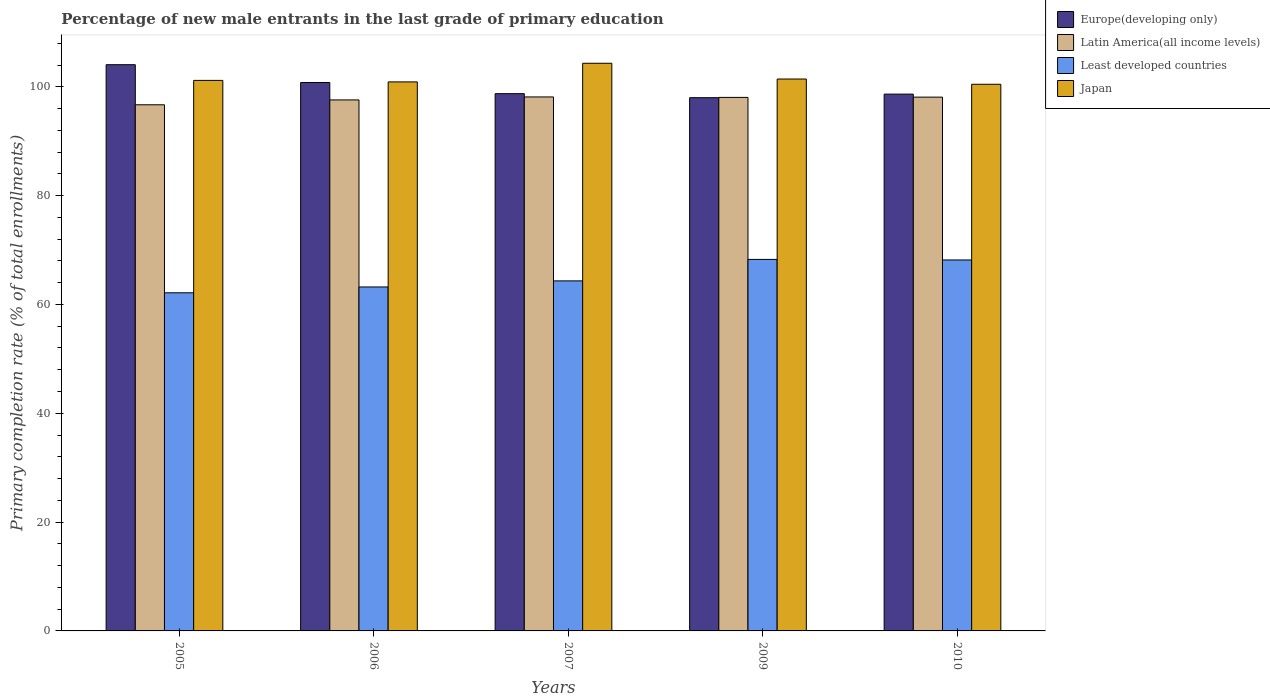How many groups of bars are there?
Provide a short and direct response. 5. Are the number of bars per tick equal to the number of legend labels?
Your response must be concise. Yes. What is the label of the 1st group of bars from the left?
Provide a short and direct response. 2005. In how many cases, is the number of bars for a given year not equal to the number of legend labels?
Give a very brief answer. 0. What is the percentage of new male entrants in Least developed countries in 2005?
Provide a succinct answer. 62.14. Across all years, what is the maximum percentage of new male entrants in Europe(developing only)?
Your answer should be compact. 104.07. Across all years, what is the minimum percentage of new male entrants in Europe(developing only)?
Your answer should be compact. 98. In which year was the percentage of new male entrants in Europe(developing only) maximum?
Your answer should be compact. 2005. What is the total percentage of new male entrants in Least developed countries in the graph?
Provide a short and direct response. 326.15. What is the difference between the percentage of new male entrants in Latin America(all income levels) in 2006 and that in 2009?
Keep it short and to the point. -0.46. What is the difference between the percentage of new male entrants in Japan in 2007 and the percentage of new male entrants in Least developed countries in 2010?
Give a very brief answer. 36.15. What is the average percentage of new male entrants in Least developed countries per year?
Your answer should be compact. 65.23. In the year 2007, what is the difference between the percentage of new male entrants in Least developed countries and percentage of new male entrants in Latin America(all income levels)?
Your response must be concise. -33.81. In how many years, is the percentage of new male entrants in Europe(developing only) greater than 100 %?
Give a very brief answer. 2. What is the ratio of the percentage of new male entrants in Latin America(all income levels) in 2006 to that in 2010?
Your answer should be compact. 0.99. Is the percentage of new male entrants in Latin America(all income levels) in 2005 less than that in 2007?
Keep it short and to the point. Yes. Is the difference between the percentage of new male entrants in Least developed countries in 2006 and 2007 greater than the difference between the percentage of new male entrants in Latin America(all income levels) in 2006 and 2007?
Offer a terse response. No. What is the difference between the highest and the second highest percentage of new male entrants in Japan?
Keep it short and to the point. 2.9. What is the difference between the highest and the lowest percentage of new male entrants in Europe(developing only)?
Ensure brevity in your answer.  6.06. Is the sum of the percentage of new male entrants in Latin America(all income levels) in 2005 and 2010 greater than the maximum percentage of new male entrants in Least developed countries across all years?
Offer a very short reply. Yes. Is it the case that in every year, the sum of the percentage of new male entrants in Latin America(all income levels) and percentage of new male entrants in Europe(developing only) is greater than the sum of percentage of new male entrants in Japan and percentage of new male entrants in Least developed countries?
Make the answer very short. Yes. How many bars are there?
Provide a succinct answer. 20. Are all the bars in the graph horizontal?
Your answer should be very brief. No. How many years are there in the graph?
Provide a succinct answer. 5. Does the graph contain any zero values?
Your answer should be very brief. No. Does the graph contain grids?
Offer a terse response. No. How many legend labels are there?
Provide a short and direct response. 4. What is the title of the graph?
Make the answer very short. Percentage of new male entrants in the last grade of primary education. Does "Venezuela" appear as one of the legend labels in the graph?
Give a very brief answer. No. What is the label or title of the X-axis?
Provide a succinct answer. Years. What is the label or title of the Y-axis?
Your answer should be very brief. Primary completion rate (% of total enrollments). What is the Primary completion rate (% of total enrollments) of Europe(developing only) in 2005?
Make the answer very short. 104.07. What is the Primary completion rate (% of total enrollments) of Latin America(all income levels) in 2005?
Ensure brevity in your answer.  96.7. What is the Primary completion rate (% of total enrollments) of Least developed countries in 2005?
Make the answer very short. 62.14. What is the Primary completion rate (% of total enrollments) in Japan in 2005?
Offer a very short reply. 101.18. What is the Primary completion rate (% of total enrollments) in Europe(developing only) in 2006?
Keep it short and to the point. 100.79. What is the Primary completion rate (% of total enrollments) in Latin America(all income levels) in 2006?
Provide a succinct answer. 97.59. What is the Primary completion rate (% of total enrollments) in Least developed countries in 2006?
Provide a succinct answer. 63.22. What is the Primary completion rate (% of total enrollments) of Japan in 2006?
Make the answer very short. 100.9. What is the Primary completion rate (% of total enrollments) of Europe(developing only) in 2007?
Your response must be concise. 98.74. What is the Primary completion rate (% of total enrollments) in Latin America(all income levels) in 2007?
Keep it short and to the point. 98.14. What is the Primary completion rate (% of total enrollments) of Least developed countries in 2007?
Provide a short and direct response. 64.33. What is the Primary completion rate (% of total enrollments) in Japan in 2007?
Keep it short and to the point. 104.33. What is the Primary completion rate (% of total enrollments) in Europe(developing only) in 2009?
Keep it short and to the point. 98. What is the Primary completion rate (% of total enrollments) in Latin America(all income levels) in 2009?
Ensure brevity in your answer.  98.06. What is the Primary completion rate (% of total enrollments) in Least developed countries in 2009?
Give a very brief answer. 68.28. What is the Primary completion rate (% of total enrollments) in Japan in 2009?
Ensure brevity in your answer.  101.43. What is the Primary completion rate (% of total enrollments) of Europe(developing only) in 2010?
Your answer should be compact. 98.66. What is the Primary completion rate (% of total enrollments) of Latin America(all income levels) in 2010?
Provide a succinct answer. 98.1. What is the Primary completion rate (% of total enrollments) of Least developed countries in 2010?
Offer a terse response. 68.18. What is the Primary completion rate (% of total enrollments) in Japan in 2010?
Provide a succinct answer. 100.47. Across all years, what is the maximum Primary completion rate (% of total enrollments) in Europe(developing only)?
Give a very brief answer. 104.07. Across all years, what is the maximum Primary completion rate (% of total enrollments) in Latin America(all income levels)?
Provide a succinct answer. 98.14. Across all years, what is the maximum Primary completion rate (% of total enrollments) of Least developed countries?
Your answer should be very brief. 68.28. Across all years, what is the maximum Primary completion rate (% of total enrollments) in Japan?
Your response must be concise. 104.33. Across all years, what is the minimum Primary completion rate (% of total enrollments) in Europe(developing only)?
Your answer should be compact. 98. Across all years, what is the minimum Primary completion rate (% of total enrollments) of Latin America(all income levels)?
Your answer should be compact. 96.7. Across all years, what is the minimum Primary completion rate (% of total enrollments) of Least developed countries?
Your answer should be very brief. 62.14. Across all years, what is the minimum Primary completion rate (% of total enrollments) in Japan?
Ensure brevity in your answer.  100.47. What is the total Primary completion rate (% of total enrollments) of Europe(developing only) in the graph?
Offer a very short reply. 500.26. What is the total Primary completion rate (% of total enrollments) of Latin America(all income levels) in the graph?
Your answer should be compact. 488.59. What is the total Primary completion rate (% of total enrollments) of Least developed countries in the graph?
Keep it short and to the point. 326.15. What is the total Primary completion rate (% of total enrollments) in Japan in the graph?
Make the answer very short. 508.31. What is the difference between the Primary completion rate (% of total enrollments) of Europe(developing only) in 2005 and that in 2006?
Your answer should be very brief. 3.28. What is the difference between the Primary completion rate (% of total enrollments) of Latin America(all income levels) in 2005 and that in 2006?
Make the answer very short. -0.9. What is the difference between the Primary completion rate (% of total enrollments) in Least developed countries in 2005 and that in 2006?
Your answer should be very brief. -1.07. What is the difference between the Primary completion rate (% of total enrollments) in Japan in 2005 and that in 2006?
Your answer should be very brief. 0.28. What is the difference between the Primary completion rate (% of total enrollments) in Europe(developing only) in 2005 and that in 2007?
Provide a succinct answer. 5.32. What is the difference between the Primary completion rate (% of total enrollments) in Latin America(all income levels) in 2005 and that in 2007?
Provide a succinct answer. -1.44. What is the difference between the Primary completion rate (% of total enrollments) of Least developed countries in 2005 and that in 2007?
Make the answer very short. -2.19. What is the difference between the Primary completion rate (% of total enrollments) of Japan in 2005 and that in 2007?
Keep it short and to the point. -3.15. What is the difference between the Primary completion rate (% of total enrollments) in Europe(developing only) in 2005 and that in 2009?
Provide a succinct answer. 6.06. What is the difference between the Primary completion rate (% of total enrollments) in Latin America(all income levels) in 2005 and that in 2009?
Your answer should be very brief. -1.36. What is the difference between the Primary completion rate (% of total enrollments) in Least developed countries in 2005 and that in 2009?
Provide a short and direct response. -6.14. What is the difference between the Primary completion rate (% of total enrollments) of Japan in 2005 and that in 2009?
Your answer should be compact. -0.25. What is the difference between the Primary completion rate (% of total enrollments) in Europe(developing only) in 2005 and that in 2010?
Give a very brief answer. 5.41. What is the difference between the Primary completion rate (% of total enrollments) of Latin America(all income levels) in 2005 and that in 2010?
Offer a terse response. -1.41. What is the difference between the Primary completion rate (% of total enrollments) of Least developed countries in 2005 and that in 2010?
Offer a very short reply. -6.04. What is the difference between the Primary completion rate (% of total enrollments) in Japan in 2005 and that in 2010?
Offer a terse response. 0.71. What is the difference between the Primary completion rate (% of total enrollments) of Europe(developing only) in 2006 and that in 2007?
Keep it short and to the point. 2.05. What is the difference between the Primary completion rate (% of total enrollments) in Latin America(all income levels) in 2006 and that in 2007?
Your response must be concise. -0.54. What is the difference between the Primary completion rate (% of total enrollments) in Least developed countries in 2006 and that in 2007?
Give a very brief answer. -1.12. What is the difference between the Primary completion rate (% of total enrollments) of Japan in 2006 and that in 2007?
Provide a succinct answer. -3.43. What is the difference between the Primary completion rate (% of total enrollments) of Europe(developing only) in 2006 and that in 2009?
Your response must be concise. 2.79. What is the difference between the Primary completion rate (% of total enrollments) in Latin America(all income levels) in 2006 and that in 2009?
Ensure brevity in your answer.  -0.46. What is the difference between the Primary completion rate (% of total enrollments) of Least developed countries in 2006 and that in 2009?
Your answer should be very brief. -5.06. What is the difference between the Primary completion rate (% of total enrollments) in Japan in 2006 and that in 2009?
Your answer should be compact. -0.53. What is the difference between the Primary completion rate (% of total enrollments) in Europe(developing only) in 2006 and that in 2010?
Your response must be concise. 2.13. What is the difference between the Primary completion rate (% of total enrollments) of Latin America(all income levels) in 2006 and that in 2010?
Provide a succinct answer. -0.51. What is the difference between the Primary completion rate (% of total enrollments) in Least developed countries in 2006 and that in 2010?
Offer a very short reply. -4.96. What is the difference between the Primary completion rate (% of total enrollments) of Japan in 2006 and that in 2010?
Your answer should be very brief. 0.44. What is the difference between the Primary completion rate (% of total enrollments) of Europe(developing only) in 2007 and that in 2009?
Make the answer very short. 0.74. What is the difference between the Primary completion rate (% of total enrollments) in Latin America(all income levels) in 2007 and that in 2009?
Offer a very short reply. 0.08. What is the difference between the Primary completion rate (% of total enrollments) of Least developed countries in 2007 and that in 2009?
Your answer should be very brief. -3.95. What is the difference between the Primary completion rate (% of total enrollments) in Japan in 2007 and that in 2009?
Your answer should be very brief. 2.9. What is the difference between the Primary completion rate (% of total enrollments) of Europe(developing only) in 2007 and that in 2010?
Your response must be concise. 0.08. What is the difference between the Primary completion rate (% of total enrollments) of Latin America(all income levels) in 2007 and that in 2010?
Ensure brevity in your answer.  0.03. What is the difference between the Primary completion rate (% of total enrollments) of Least developed countries in 2007 and that in 2010?
Your answer should be very brief. -3.85. What is the difference between the Primary completion rate (% of total enrollments) of Japan in 2007 and that in 2010?
Provide a succinct answer. 3.86. What is the difference between the Primary completion rate (% of total enrollments) of Europe(developing only) in 2009 and that in 2010?
Offer a very short reply. -0.65. What is the difference between the Primary completion rate (% of total enrollments) of Latin America(all income levels) in 2009 and that in 2010?
Give a very brief answer. -0.05. What is the difference between the Primary completion rate (% of total enrollments) in Least developed countries in 2009 and that in 2010?
Ensure brevity in your answer.  0.1. What is the difference between the Primary completion rate (% of total enrollments) in Japan in 2009 and that in 2010?
Your answer should be very brief. 0.97. What is the difference between the Primary completion rate (% of total enrollments) in Europe(developing only) in 2005 and the Primary completion rate (% of total enrollments) in Latin America(all income levels) in 2006?
Give a very brief answer. 6.47. What is the difference between the Primary completion rate (% of total enrollments) in Europe(developing only) in 2005 and the Primary completion rate (% of total enrollments) in Least developed countries in 2006?
Keep it short and to the point. 40.85. What is the difference between the Primary completion rate (% of total enrollments) in Europe(developing only) in 2005 and the Primary completion rate (% of total enrollments) in Japan in 2006?
Provide a succinct answer. 3.16. What is the difference between the Primary completion rate (% of total enrollments) of Latin America(all income levels) in 2005 and the Primary completion rate (% of total enrollments) of Least developed countries in 2006?
Your response must be concise. 33.48. What is the difference between the Primary completion rate (% of total enrollments) in Latin America(all income levels) in 2005 and the Primary completion rate (% of total enrollments) in Japan in 2006?
Provide a succinct answer. -4.21. What is the difference between the Primary completion rate (% of total enrollments) of Least developed countries in 2005 and the Primary completion rate (% of total enrollments) of Japan in 2006?
Offer a terse response. -38.76. What is the difference between the Primary completion rate (% of total enrollments) of Europe(developing only) in 2005 and the Primary completion rate (% of total enrollments) of Latin America(all income levels) in 2007?
Your answer should be compact. 5.93. What is the difference between the Primary completion rate (% of total enrollments) in Europe(developing only) in 2005 and the Primary completion rate (% of total enrollments) in Least developed countries in 2007?
Provide a succinct answer. 39.73. What is the difference between the Primary completion rate (% of total enrollments) of Europe(developing only) in 2005 and the Primary completion rate (% of total enrollments) of Japan in 2007?
Give a very brief answer. -0.26. What is the difference between the Primary completion rate (% of total enrollments) in Latin America(all income levels) in 2005 and the Primary completion rate (% of total enrollments) in Least developed countries in 2007?
Keep it short and to the point. 32.36. What is the difference between the Primary completion rate (% of total enrollments) in Latin America(all income levels) in 2005 and the Primary completion rate (% of total enrollments) in Japan in 2007?
Your answer should be compact. -7.63. What is the difference between the Primary completion rate (% of total enrollments) of Least developed countries in 2005 and the Primary completion rate (% of total enrollments) of Japan in 2007?
Your answer should be very brief. -42.19. What is the difference between the Primary completion rate (% of total enrollments) of Europe(developing only) in 2005 and the Primary completion rate (% of total enrollments) of Latin America(all income levels) in 2009?
Your answer should be very brief. 6.01. What is the difference between the Primary completion rate (% of total enrollments) in Europe(developing only) in 2005 and the Primary completion rate (% of total enrollments) in Least developed countries in 2009?
Offer a very short reply. 35.79. What is the difference between the Primary completion rate (% of total enrollments) in Europe(developing only) in 2005 and the Primary completion rate (% of total enrollments) in Japan in 2009?
Provide a short and direct response. 2.63. What is the difference between the Primary completion rate (% of total enrollments) of Latin America(all income levels) in 2005 and the Primary completion rate (% of total enrollments) of Least developed countries in 2009?
Offer a terse response. 28.42. What is the difference between the Primary completion rate (% of total enrollments) in Latin America(all income levels) in 2005 and the Primary completion rate (% of total enrollments) in Japan in 2009?
Your answer should be compact. -4.73. What is the difference between the Primary completion rate (% of total enrollments) of Least developed countries in 2005 and the Primary completion rate (% of total enrollments) of Japan in 2009?
Offer a terse response. -39.29. What is the difference between the Primary completion rate (% of total enrollments) in Europe(developing only) in 2005 and the Primary completion rate (% of total enrollments) in Latin America(all income levels) in 2010?
Your answer should be compact. 5.96. What is the difference between the Primary completion rate (% of total enrollments) in Europe(developing only) in 2005 and the Primary completion rate (% of total enrollments) in Least developed countries in 2010?
Keep it short and to the point. 35.89. What is the difference between the Primary completion rate (% of total enrollments) of Europe(developing only) in 2005 and the Primary completion rate (% of total enrollments) of Japan in 2010?
Your answer should be very brief. 3.6. What is the difference between the Primary completion rate (% of total enrollments) in Latin America(all income levels) in 2005 and the Primary completion rate (% of total enrollments) in Least developed countries in 2010?
Make the answer very short. 28.52. What is the difference between the Primary completion rate (% of total enrollments) of Latin America(all income levels) in 2005 and the Primary completion rate (% of total enrollments) of Japan in 2010?
Offer a terse response. -3.77. What is the difference between the Primary completion rate (% of total enrollments) of Least developed countries in 2005 and the Primary completion rate (% of total enrollments) of Japan in 2010?
Your answer should be compact. -38.32. What is the difference between the Primary completion rate (% of total enrollments) in Europe(developing only) in 2006 and the Primary completion rate (% of total enrollments) in Latin America(all income levels) in 2007?
Keep it short and to the point. 2.65. What is the difference between the Primary completion rate (% of total enrollments) of Europe(developing only) in 2006 and the Primary completion rate (% of total enrollments) of Least developed countries in 2007?
Offer a terse response. 36.46. What is the difference between the Primary completion rate (% of total enrollments) in Europe(developing only) in 2006 and the Primary completion rate (% of total enrollments) in Japan in 2007?
Keep it short and to the point. -3.54. What is the difference between the Primary completion rate (% of total enrollments) in Latin America(all income levels) in 2006 and the Primary completion rate (% of total enrollments) in Least developed countries in 2007?
Give a very brief answer. 33.26. What is the difference between the Primary completion rate (% of total enrollments) in Latin America(all income levels) in 2006 and the Primary completion rate (% of total enrollments) in Japan in 2007?
Your response must be concise. -6.74. What is the difference between the Primary completion rate (% of total enrollments) of Least developed countries in 2006 and the Primary completion rate (% of total enrollments) of Japan in 2007?
Make the answer very short. -41.11. What is the difference between the Primary completion rate (% of total enrollments) of Europe(developing only) in 2006 and the Primary completion rate (% of total enrollments) of Latin America(all income levels) in 2009?
Offer a very short reply. 2.74. What is the difference between the Primary completion rate (% of total enrollments) of Europe(developing only) in 2006 and the Primary completion rate (% of total enrollments) of Least developed countries in 2009?
Offer a very short reply. 32.51. What is the difference between the Primary completion rate (% of total enrollments) in Europe(developing only) in 2006 and the Primary completion rate (% of total enrollments) in Japan in 2009?
Your answer should be compact. -0.64. What is the difference between the Primary completion rate (% of total enrollments) of Latin America(all income levels) in 2006 and the Primary completion rate (% of total enrollments) of Least developed countries in 2009?
Offer a terse response. 29.31. What is the difference between the Primary completion rate (% of total enrollments) in Latin America(all income levels) in 2006 and the Primary completion rate (% of total enrollments) in Japan in 2009?
Make the answer very short. -3.84. What is the difference between the Primary completion rate (% of total enrollments) in Least developed countries in 2006 and the Primary completion rate (% of total enrollments) in Japan in 2009?
Make the answer very short. -38.22. What is the difference between the Primary completion rate (% of total enrollments) in Europe(developing only) in 2006 and the Primary completion rate (% of total enrollments) in Latin America(all income levels) in 2010?
Provide a succinct answer. 2.69. What is the difference between the Primary completion rate (% of total enrollments) of Europe(developing only) in 2006 and the Primary completion rate (% of total enrollments) of Least developed countries in 2010?
Offer a terse response. 32.61. What is the difference between the Primary completion rate (% of total enrollments) of Europe(developing only) in 2006 and the Primary completion rate (% of total enrollments) of Japan in 2010?
Offer a very short reply. 0.32. What is the difference between the Primary completion rate (% of total enrollments) in Latin America(all income levels) in 2006 and the Primary completion rate (% of total enrollments) in Least developed countries in 2010?
Provide a succinct answer. 29.41. What is the difference between the Primary completion rate (% of total enrollments) in Latin America(all income levels) in 2006 and the Primary completion rate (% of total enrollments) in Japan in 2010?
Give a very brief answer. -2.87. What is the difference between the Primary completion rate (% of total enrollments) of Least developed countries in 2006 and the Primary completion rate (% of total enrollments) of Japan in 2010?
Give a very brief answer. -37.25. What is the difference between the Primary completion rate (% of total enrollments) in Europe(developing only) in 2007 and the Primary completion rate (% of total enrollments) in Latin America(all income levels) in 2009?
Provide a succinct answer. 0.69. What is the difference between the Primary completion rate (% of total enrollments) in Europe(developing only) in 2007 and the Primary completion rate (% of total enrollments) in Least developed countries in 2009?
Your response must be concise. 30.46. What is the difference between the Primary completion rate (% of total enrollments) in Europe(developing only) in 2007 and the Primary completion rate (% of total enrollments) in Japan in 2009?
Your answer should be compact. -2.69. What is the difference between the Primary completion rate (% of total enrollments) of Latin America(all income levels) in 2007 and the Primary completion rate (% of total enrollments) of Least developed countries in 2009?
Keep it short and to the point. 29.86. What is the difference between the Primary completion rate (% of total enrollments) in Latin America(all income levels) in 2007 and the Primary completion rate (% of total enrollments) in Japan in 2009?
Offer a very short reply. -3.29. What is the difference between the Primary completion rate (% of total enrollments) of Least developed countries in 2007 and the Primary completion rate (% of total enrollments) of Japan in 2009?
Offer a very short reply. -37.1. What is the difference between the Primary completion rate (% of total enrollments) in Europe(developing only) in 2007 and the Primary completion rate (% of total enrollments) in Latin America(all income levels) in 2010?
Your answer should be compact. 0.64. What is the difference between the Primary completion rate (% of total enrollments) in Europe(developing only) in 2007 and the Primary completion rate (% of total enrollments) in Least developed countries in 2010?
Give a very brief answer. 30.56. What is the difference between the Primary completion rate (% of total enrollments) of Europe(developing only) in 2007 and the Primary completion rate (% of total enrollments) of Japan in 2010?
Offer a terse response. -1.73. What is the difference between the Primary completion rate (% of total enrollments) in Latin America(all income levels) in 2007 and the Primary completion rate (% of total enrollments) in Least developed countries in 2010?
Your response must be concise. 29.96. What is the difference between the Primary completion rate (% of total enrollments) of Latin America(all income levels) in 2007 and the Primary completion rate (% of total enrollments) of Japan in 2010?
Make the answer very short. -2.33. What is the difference between the Primary completion rate (% of total enrollments) in Least developed countries in 2007 and the Primary completion rate (% of total enrollments) in Japan in 2010?
Offer a very short reply. -36.13. What is the difference between the Primary completion rate (% of total enrollments) in Europe(developing only) in 2009 and the Primary completion rate (% of total enrollments) in Latin America(all income levels) in 2010?
Provide a short and direct response. -0.1. What is the difference between the Primary completion rate (% of total enrollments) of Europe(developing only) in 2009 and the Primary completion rate (% of total enrollments) of Least developed countries in 2010?
Offer a very short reply. 29.82. What is the difference between the Primary completion rate (% of total enrollments) in Europe(developing only) in 2009 and the Primary completion rate (% of total enrollments) in Japan in 2010?
Your answer should be very brief. -2.46. What is the difference between the Primary completion rate (% of total enrollments) in Latin America(all income levels) in 2009 and the Primary completion rate (% of total enrollments) in Least developed countries in 2010?
Keep it short and to the point. 29.88. What is the difference between the Primary completion rate (% of total enrollments) in Latin America(all income levels) in 2009 and the Primary completion rate (% of total enrollments) in Japan in 2010?
Ensure brevity in your answer.  -2.41. What is the difference between the Primary completion rate (% of total enrollments) of Least developed countries in 2009 and the Primary completion rate (% of total enrollments) of Japan in 2010?
Your answer should be compact. -32.19. What is the average Primary completion rate (% of total enrollments) of Europe(developing only) per year?
Offer a terse response. 100.05. What is the average Primary completion rate (% of total enrollments) of Latin America(all income levels) per year?
Offer a very short reply. 97.72. What is the average Primary completion rate (% of total enrollments) of Least developed countries per year?
Your answer should be very brief. 65.23. What is the average Primary completion rate (% of total enrollments) in Japan per year?
Ensure brevity in your answer.  101.66. In the year 2005, what is the difference between the Primary completion rate (% of total enrollments) of Europe(developing only) and Primary completion rate (% of total enrollments) of Latin America(all income levels)?
Provide a succinct answer. 7.37. In the year 2005, what is the difference between the Primary completion rate (% of total enrollments) of Europe(developing only) and Primary completion rate (% of total enrollments) of Least developed countries?
Your answer should be very brief. 41.92. In the year 2005, what is the difference between the Primary completion rate (% of total enrollments) in Europe(developing only) and Primary completion rate (% of total enrollments) in Japan?
Offer a very short reply. 2.89. In the year 2005, what is the difference between the Primary completion rate (% of total enrollments) in Latin America(all income levels) and Primary completion rate (% of total enrollments) in Least developed countries?
Your response must be concise. 34.55. In the year 2005, what is the difference between the Primary completion rate (% of total enrollments) in Latin America(all income levels) and Primary completion rate (% of total enrollments) in Japan?
Provide a succinct answer. -4.48. In the year 2005, what is the difference between the Primary completion rate (% of total enrollments) in Least developed countries and Primary completion rate (% of total enrollments) in Japan?
Offer a terse response. -39.04. In the year 2006, what is the difference between the Primary completion rate (% of total enrollments) of Europe(developing only) and Primary completion rate (% of total enrollments) of Latin America(all income levels)?
Provide a short and direct response. 3.2. In the year 2006, what is the difference between the Primary completion rate (% of total enrollments) of Europe(developing only) and Primary completion rate (% of total enrollments) of Least developed countries?
Keep it short and to the point. 37.57. In the year 2006, what is the difference between the Primary completion rate (% of total enrollments) in Europe(developing only) and Primary completion rate (% of total enrollments) in Japan?
Your response must be concise. -0.11. In the year 2006, what is the difference between the Primary completion rate (% of total enrollments) of Latin America(all income levels) and Primary completion rate (% of total enrollments) of Least developed countries?
Make the answer very short. 34.38. In the year 2006, what is the difference between the Primary completion rate (% of total enrollments) of Latin America(all income levels) and Primary completion rate (% of total enrollments) of Japan?
Keep it short and to the point. -3.31. In the year 2006, what is the difference between the Primary completion rate (% of total enrollments) in Least developed countries and Primary completion rate (% of total enrollments) in Japan?
Keep it short and to the point. -37.69. In the year 2007, what is the difference between the Primary completion rate (% of total enrollments) of Europe(developing only) and Primary completion rate (% of total enrollments) of Latin America(all income levels)?
Offer a terse response. 0.6. In the year 2007, what is the difference between the Primary completion rate (% of total enrollments) of Europe(developing only) and Primary completion rate (% of total enrollments) of Least developed countries?
Provide a succinct answer. 34.41. In the year 2007, what is the difference between the Primary completion rate (% of total enrollments) in Europe(developing only) and Primary completion rate (% of total enrollments) in Japan?
Your response must be concise. -5.59. In the year 2007, what is the difference between the Primary completion rate (% of total enrollments) of Latin America(all income levels) and Primary completion rate (% of total enrollments) of Least developed countries?
Offer a terse response. 33.81. In the year 2007, what is the difference between the Primary completion rate (% of total enrollments) of Latin America(all income levels) and Primary completion rate (% of total enrollments) of Japan?
Provide a succinct answer. -6.19. In the year 2007, what is the difference between the Primary completion rate (% of total enrollments) of Least developed countries and Primary completion rate (% of total enrollments) of Japan?
Provide a short and direct response. -40. In the year 2009, what is the difference between the Primary completion rate (% of total enrollments) of Europe(developing only) and Primary completion rate (% of total enrollments) of Latin America(all income levels)?
Offer a terse response. -0.05. In the year 2009, what is the difference between the Primary completion rate (% of total enrollments) of Europe(developing only) and Primary completion rate (% of total enrollments) of Least developed countries?
Your answer should be compact. 29.73. In the year 2009, what is the difference between the Primary completion rate (% of total enrollments) of Europe(developing only) and Primary completion rate (% of total enrollments) of Japan?
Your answer should be very brief. -3.43. In the year 2009, what is the difference between the Primary completion rate (% of total enrollments) in Latin America(all income levels) and Primary completion rate (% of total enrollments) in Least developed countries?
Ensure brevity in your answer.  29.78. In the year 2009, what is the difference between the Primary completion rate (% of total enrollments) of Latin America(all income levels) and Primary completion rate (% of total enrollments) of Japan?
Offer a very short reply. -3.38. In the year 2009, what is the difference between the Primary completion rate (% of total enrollments) of Least developed countries and Primary completion rate (% of total enrollments) of Japan?
Your answer should be very brief. -33.15. In the year 2010, what is the difference between the Primary completion rate (% of total enrollments) of Europe(developing only) and Primary completion rate (% of total enrollments) of Latin America(all income levels)?
Keep it short and to the point. 0.55. In the year 2010, what is the difference between the Primary completion rate (% of total enrollments) of Europe(developing only) and Primary completion rate (% of total enrollments) of Least developed countries?
Provide a succinct answer. 30.48. In the year 2010, what is the difference between the Primary completion rate (% of total enrollments) in Europe(developing only) and Primary completion rate (% of total enrollments) in Japan?
Provide a succinct answer. -1.81. In the year 2010, what is the difference between the Primary completion rate (% of total enrollments) in Latin America(all income levels) and Primary completion rate (% of total enrollments) in Least developed countries?
Offer a very short reply. 29.92. In the year 2010, what is the difference between the Primary completion rate (% of total enrollments) of Latin America(all income levels) and Primary completion rate (% of total enrollments) of Japan?
Offer a terse response. -2.36. In the year 2010, what is the difference between the Primary completion rate (% of total enrollments) in Least developed countries and Primary completion rate (% of total enrollments) in Japan?
Keep it short and to the point. -32.29. What is the ratio of the Primary completion rate (% of total enrollments) of Europe(developing only) in 2005 to that in 2006?
Your response must be concise. 1.03. What is the ratio of the Primary completion rate (% of total enrollments) of Europe(developing only) in 2005 to that in 2007?
Provide a succinct answer. 1.05. What is the ratio of the Primary completion rate (% of total enrollments) of Latin America(all income levels) in 2005 to that in 2007?
Make the answer very short. 0.99. What is the ratio of the Primary completion rate (% of total enrollments) of Japan in 2005 to that in 2007?
Provide a short and direct response. 0.97. What is the ratio of the Primary completion rate (% of total enrollments) in Europe(developing only) in 2005 to that in 2009?
Offer a terse response. 1.06. What is the ratio of the Primary completion rate (% of total enrollments) in Latin America(all income levels) in 2005 to that in 2009?
Your answer should be compact. 0.99. What is the ratio of the Primary completion rate (% of total enrollments) of Least developed countries in 2005 to that in 2009?
Ensure brevity in your answer.  0.91. What is the ratio of the Primary completion rate (% of total enrollments) of Japan in 2005 to that in 2009?
Ensure brevity in your answer.  1. What is the ratio of the Primary completion rate (% of total enrollments) in Europe(developing only) in 2005 to that in 2010?
Ensure brevity in your answer.  1.05. What is the ratio of the Primary completion rate (% of total enrollments) of Latin America(all income levels) in 2005 to that in 2010?
Offer a terse response. 0.99. What is the ratio of the Primary completion rate (% of total enrollments) in Least developed countries in 2005 to that in 2010?
Your answer should be very brief. 0.91. What is the ratio of the Primary completion rate (% of total enrollments) in Japan in 2005 to that in 2010?
Your answer should be very brief. 1.01. What is the ratio of the Primary completion rate (% of total enrollments) of Europe(developing only) in 2006 to that in 2007?
Give a very brief answer. 1.02. What is the ratio of the Primary completion rate (% of total enrollments) of Latin America(all income levels) in 2006 to that in 2007?
Offer a very short reply. 0.99. What is the ratio of the Primary completion rate (% of total enrollments) of Least developed countries in 2006 to that in 2007?
Your answer should be very brief. 0.98. What is the ratio of the Primary completion rate (% of total enrollments) of Japan in 2006 to that in 2007?
Your answer should be compact. 0.97. What is the ratio of the Primary completion rate (% of total enrollments) of Europe(developing only) in 2006 to that in 2009?
Provide a succinct answer. 1.03. What is the ratio of the Primary completion rate (% of total enrollments) of Latin America(all income levels) in 2006 to that in 2009?
Give a very brief answer. 1. What is the ratio of the Primary completion rate (% of total enrollments) in Least developed countries in 2006 to that in 2009?
Your answer should be very brief. 0.93. What is the ratio of the Primary completion rate (% of total enrollments) of Europe(developing only) in 2006 to that in 2010?
Provide a short and direct response. 1.02. What is the ratio of the Primary completion rate (% of total enrollments) in Least developed countries in 2006 to that in 2010?
Make the answer very short. 0.93. What is the ratio of the Primary completion rate (% of total enrollments) in Europe(developing only) in 2007 to that in 2009?
Give a very brief answer. 1.01. What is the ratio of the Primary completion rate (% of total enrollments) in Latin America(all income levels) in 2007 to that in 2009?
Ensure brevity in your answer.  1. What is the ratio of the Primary completion rate (% of total enrollments) in Least developed countries in 2007 to that in 2009?
Make the answer very short. 0.94. What is the ratio of the Primary completion rate (% of total enrollments) in Japan in 2007 to that in 2009?
Your response must be concise. 1.03. What is the ratio of the Primary completion rate (% of total enrollments) in Europe(developing only) in 2007 to that in 2010?
Provide a short and direct response. 1. What is the ratio of the Primary completion rate (% of total enrollments) of Least developed countries in 2007 to that in 2010?
Make the answer very short. 0.94. What is the ratio of the Primary completion rate (% of total enrollments) in Japan in 2007 to that in 2010?
Make the answer very short. 1.04. What is the ratio of the Primary completion rate (% of total enrollments) in Europe(developing only) in 2009 to that in 2010?
Your answer should be compact. 0.99. What is the ratio of the Primary completion rate (% of total enrollments) of Japan in 2009 to that in 2010?
Your answer should be very brief. 1.01. What is the difference between the highest and the second highest Primary completion rate (% of total enrollments) in Europe(developing only)?
Provide a succinct answer. 3.28. What is the difference between the highest and the second highest Primary completion rate (% of total enrollments) in Latin America(all income levels)?
Your answer should be compact. 0.03. What is the difference between the highest and the second highest Primary completion rate (% of total enrollments) in Least developed countries?
Your answer should be very brief. 0.1. What is the difference between the highest and the second highest Primary completion rate (% of total enrollments) in Japan?
Your answer should be compact. 2.9. What is the difference between the highest and the lowest Primary completion rate (% of total enrollments) of Europe(developing only)?
Your response must be concise. 6.06. What is the difference between the highest and the lowest Primary completion rate (% of total enrollments) of Latin America(all income levels)?
Provide a short and direct response. 1.44. What is the difference between the highest and the lowest Primary completion rate (% of total enrollments) in Least developed countries?
Make the answer very short. 6.14. What is the difference between the highest and the lowest Primary completion rate (% of total enrollments) of Japan?
Provide a succinct answer. 3.86. 